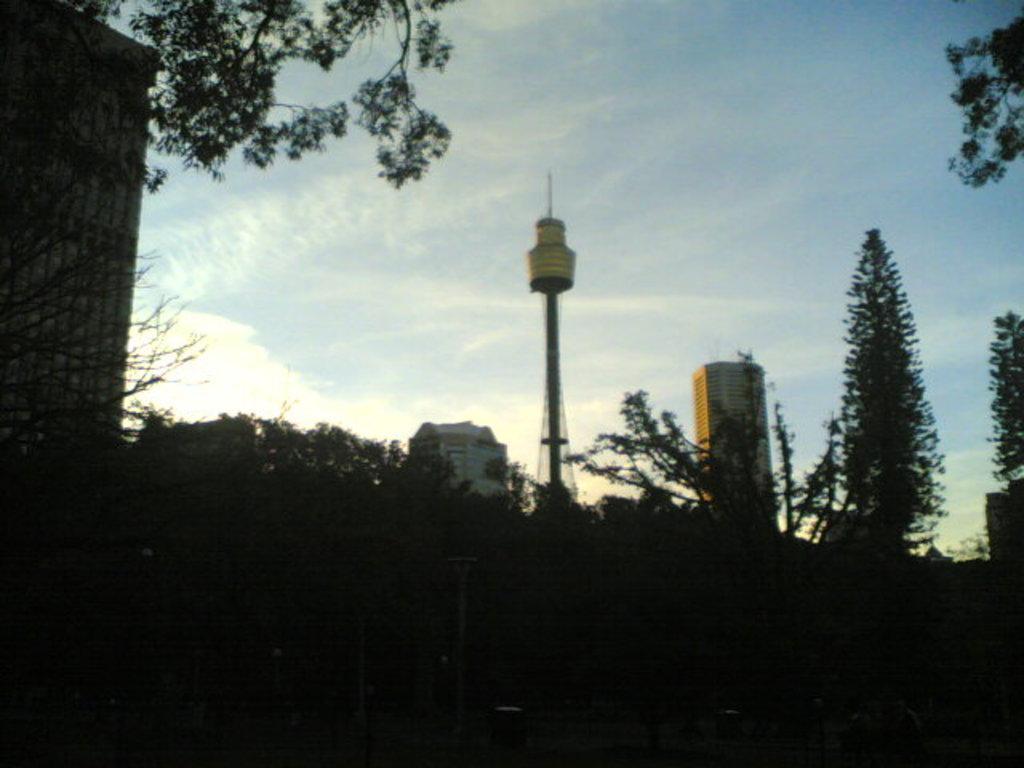Describe this image in one or two sentences. This image is clicked in dark I can see a tower in the center of the image I can see sky at the top of the image and some buildings and some plants and trees at the right side of the image. 